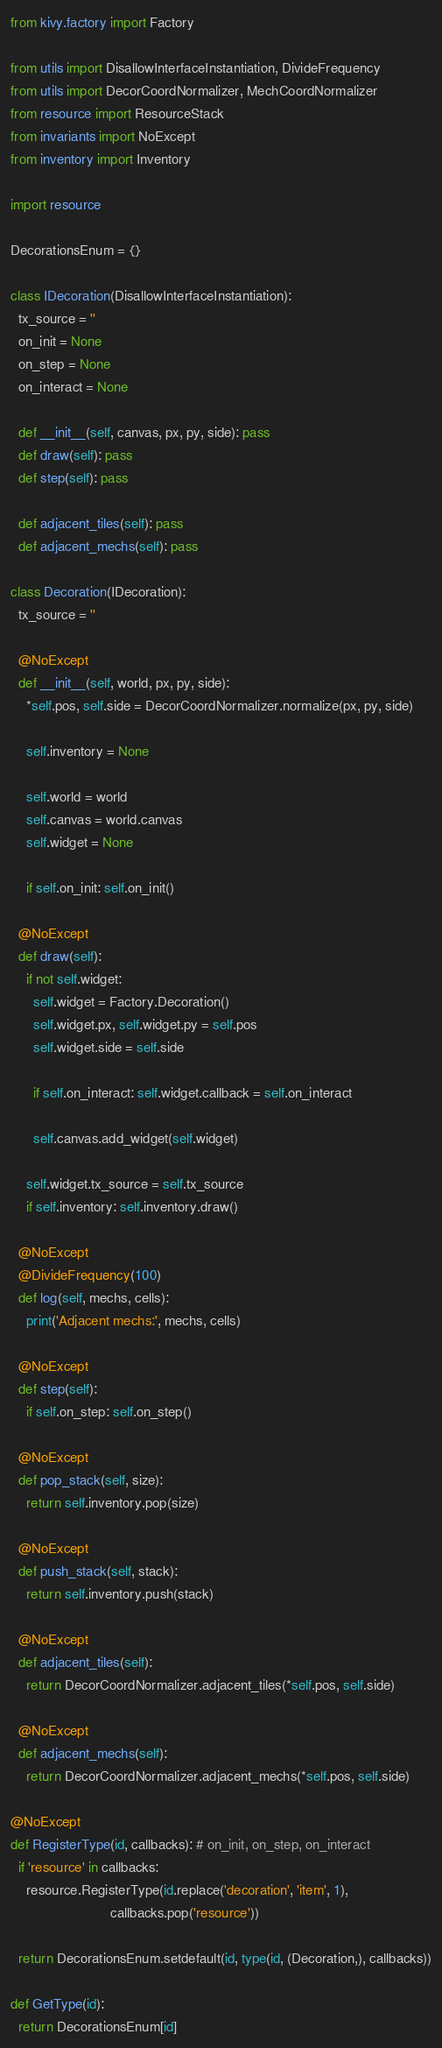<code> <loc_0><loc_0><loc_500><loc_500><_Python_>from kivy.factory import Factory

from utils import DisallowInterfaceInstantiation, DivideFrequency
from utils import DecorCoordNormalizer, MechCoordNormalizer
from resource import ResourceStack
from invariants import NoExcept
from inventory import Inventory

import resource

DecorationsEnum = {}

class IDecoration(DisallowInterfaceInstantiation):
  tx_source = ''
  on_init = None
  on_step = None
  on_interact = None
  
  def __init__(self, canvas, px, py, side): pass
  def draw(self): pass
  def step(self): pass
  
  def adjacent_tiles(self): pass
  def adjacent_mechs(self): pass

class Decoration(IDecoration):
  tx_source = ''
  
  @NoExcept
  def __init__(self, world, px, py, side):
    *self.pos, self.side = DecorCoordNormalizer.normalize(px, py, side)
    
    self.inventory = None
    
    self.world = world
    self.canvas = world.canvas
    self.widget = None
    
    if self.on_init: self.on_init()
  
  @NoExcept
  def draw(self):
    if not self.widget:
      self.widget = Factory.Decoration()
      self.widget.px, self.widget.py = self.pos
      self.widget.side = self.side
      
      if self.on_interact: self.widget.callback = self.on_interact
      
      self.canvas.add_widget(self.widget)
    
    self.widget.tx_source = self.tx_source
    if self.inventory: self.inventory.draw()
  
  @NoExcept
  @DivideFrequency(100)
  def log(self, mechs, cells):
    print('Adjacent mechs:', mechs, cells)
  
  @NoExcept
  def step(self):
    if self.on_step: self.on_step()
  
  @NoExcept
  def pop_stack(self, size):
    return self.inventory.pop(size)
  
  @NoExcept
  def push_stack(self, stack):
    return self.inventory.push(stack)
  
  @NoExcept
  def adjacent_tiles(self):
    return DecorCoordNormalizer.adjacent_tiles(*self.pos, self.side)
  
  @NoExcept
  def adjacent_mechs(self):
    return DecorCoordNormalizer.adjacent_mechs(*self.pos, self.side)

@NoExcept
def RegisterType(id, callbacks): # on_init, on_step, on_interact
  if 'resource' in callbacks:
    resource.RegisterType(id.replace('decoration', 'item', 1),
                          callbacks.pop('resource'))
  
  return DecorationsEnum.setdefault(id, type(id, (Decoration,), callbacks))

def GetType(id):
  return DecorationsEnum[id]
</code> 